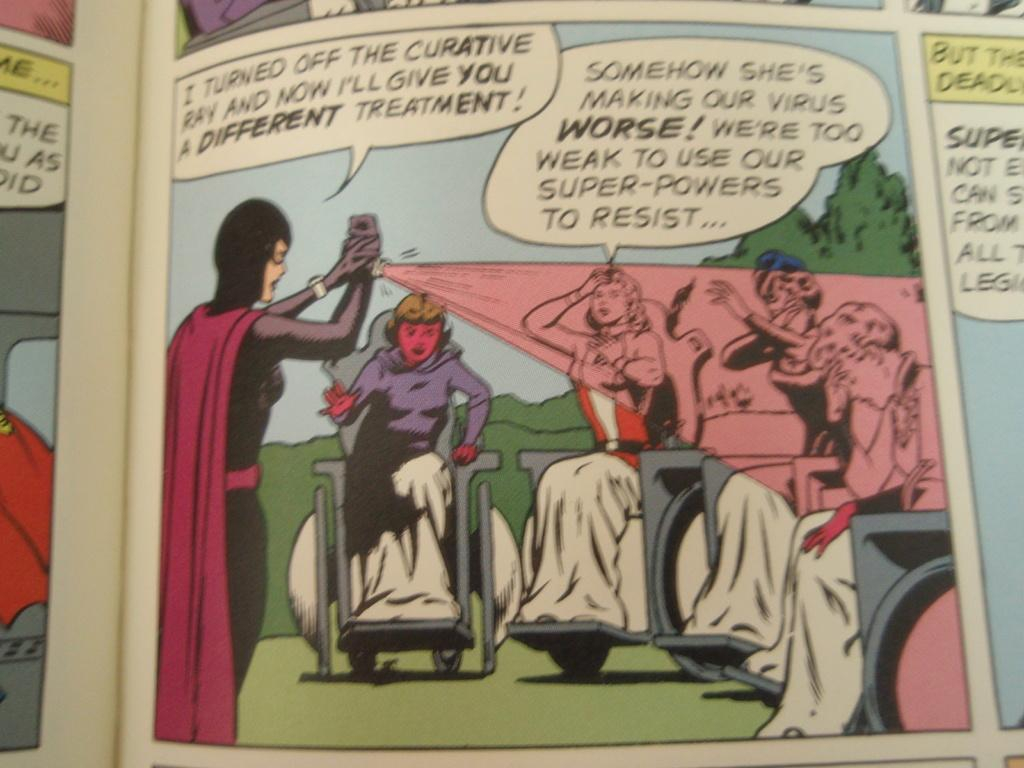Provide a one-sentence caption for the provided image. People in wheelchairs are sick with a virus. 